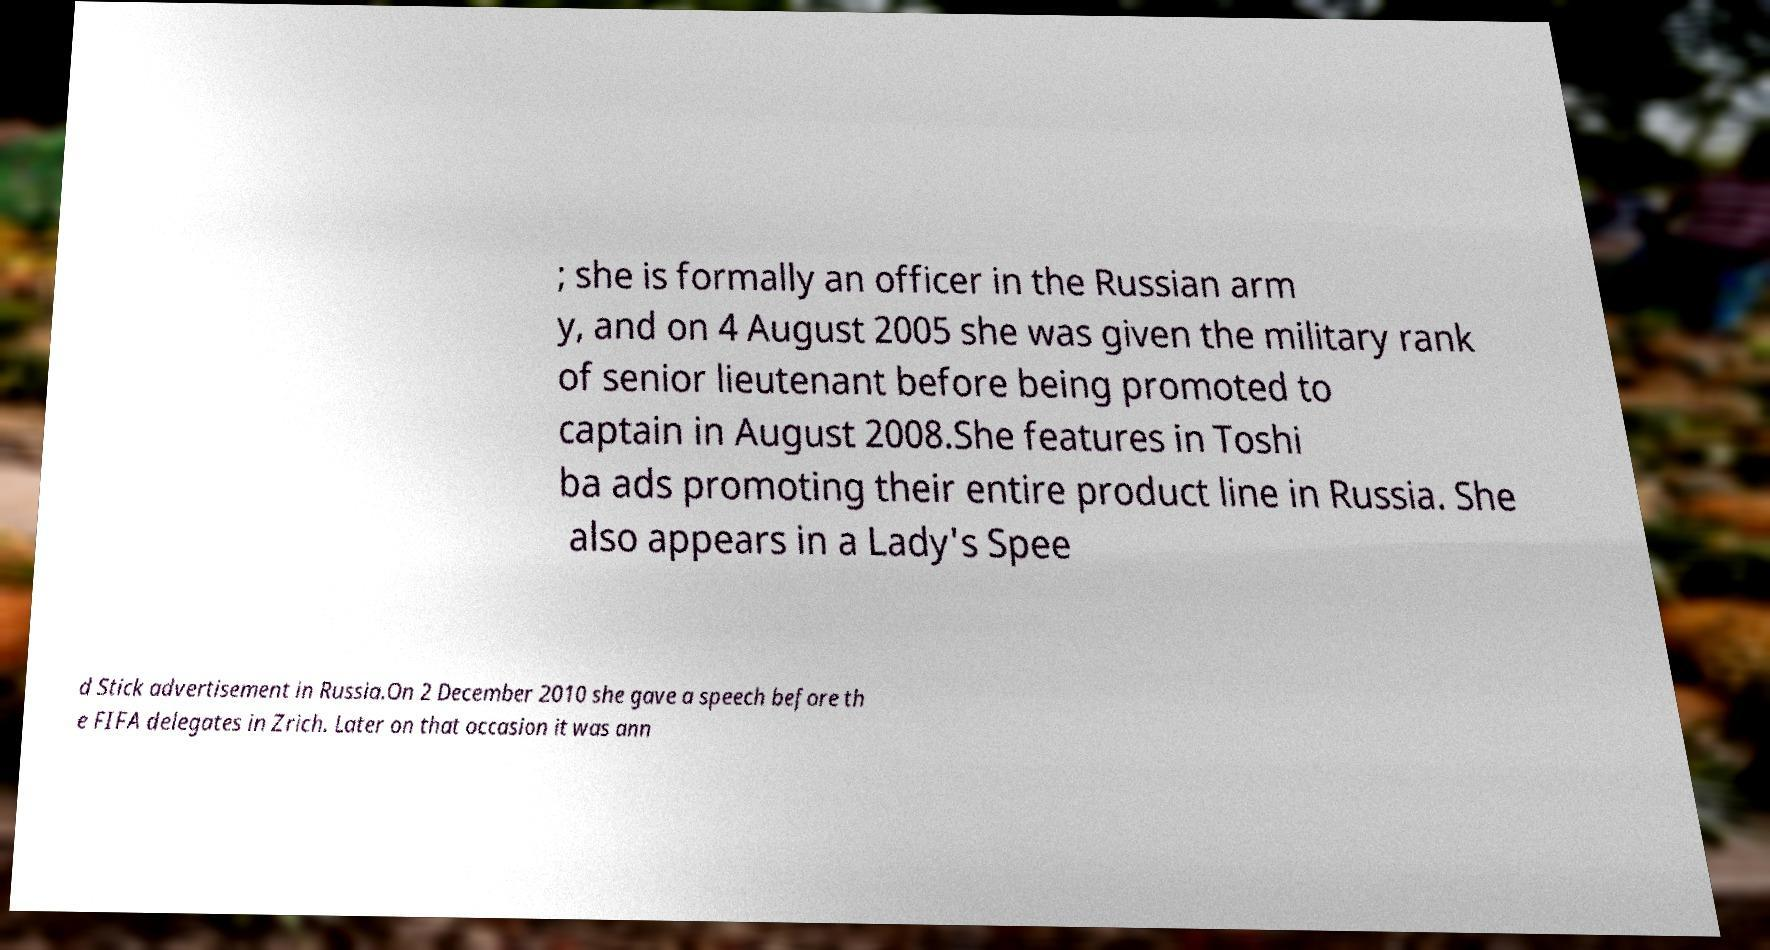Can you accurately transcribe the text from the provided image for me? ; she is formally an officer in the Russian arm y, and on 4 August 2005 she was given the military rank of senior lieutenant before being promoted to captain in August 2008.She features in Toshi ba ads promoting their entire product line in Russia. She also appears in a Lady's Spee d Stick advertisement in Russia.On 2 December 2010 she gave a speech before th e FIFA delegates in Zrich. Later on that occasion it was ann 